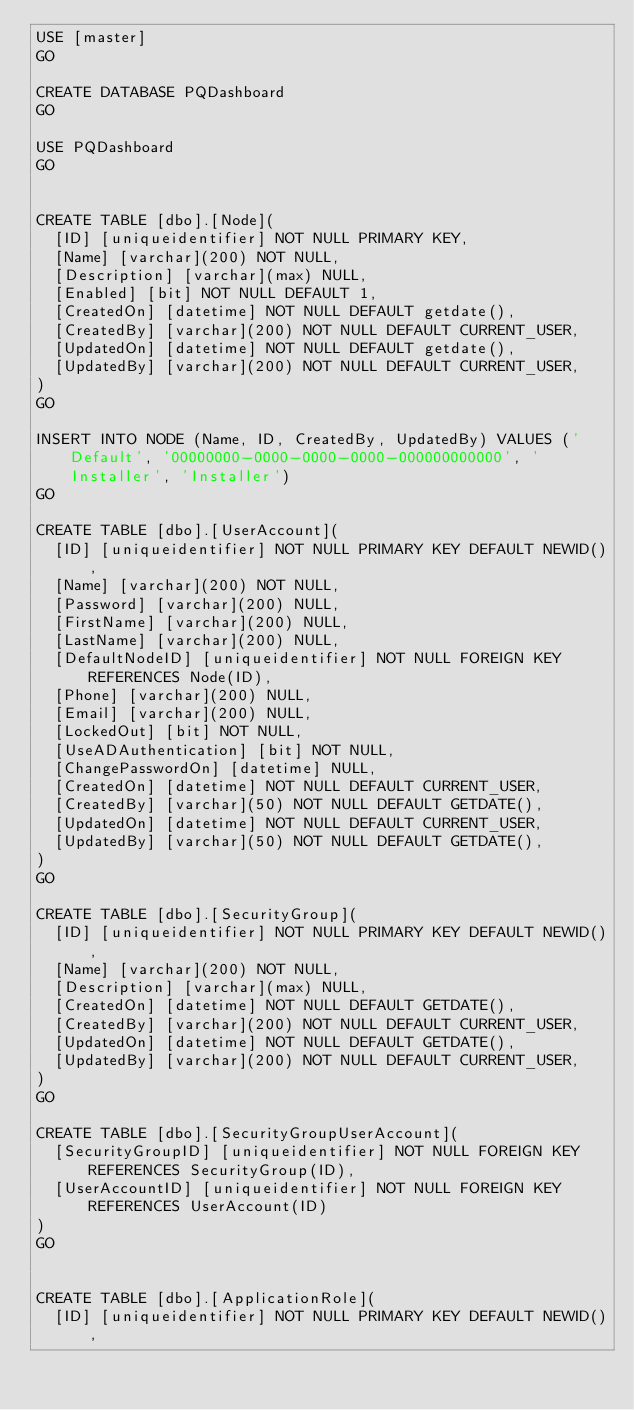<code> <loc_0><loc_0><loc_500><loc_500><_SQL_>USE [master]
GO

CREATE DATABASE PQDashboard
GO

USE PQDashboard
GO


CREATE TABLE [dbo].[Node](
	[ID] [uniqueidentifier] NOT NULL PRIMARY KEY,
	[Name] [varchar](200) NOT NULL,
	[Description] [varchar](max) NULL,
	[Enabled] [bit] NOT NULL DEFAULT 1,
	[CreatedOn] [datetime] NOT NULL DEFAULT getdate(),
	[CreatedBy] [varchar](200) NOT NULL DEFAULT CURRENT_USER,
	[UpdatedOn] [datetime] NOT NULL DEFAULT getdate(),
	[UpdatedBy] [varchar](200) NOT NULL DEFAULT CURRENT_USER,
)
GO

INSERT INTO NODE (Name, ID, CreatedBy, UpdatedBy) VALUES ('Default', '00000000-0000-0000-0000-000000000000', 'Installer', 'Installer')
GO

CREATE TABLE [dbo].[UserAccount](
	[ID] [uniqueidentifier] NOT NULL PRIMARY KEY DEFAULT NEWID(),
	[Name] [varchar](200) NOT NULL,
	[Password] [varchar](200) NULL,
	[FirstName] [varchar](200) NULL,
	[LastName] [varchar](200) NULL,
	[DefaultNodeID] [uniqueidentifier] NOT NULL FOREIGN KEY REFERENCES Node(ID),
	[Phone] [varchar](200) NULL,
	[Email] [varchar](200) NULL,
	[LockedOut] [bit] NOT NULL,
	[UseADAuthentication] [bit] NOT NULL,
	[ChangePasswordOn] [datetime] NULL,
	[CreatedOn] [datetime] NOT NULL DEFAULT CURRENT_USER,
	[CreatedBy] [varchar](50) NOT NULL DEFAULT GETDATE(),
	[UpdatedOn] [datetime] NOT NULL DEFAULT CURRENT_USER,
	[UpdatedBy] [varchar](50) NOT NULL DEFAULT GETDATE(),
)
GO

CREATE TABLE [dbo].[SecurityGroup](
	[ID] [uniqueidentifier] NOT NULL PRIMARY KEY DEFAULT NEWID(),
	[Name] [varchar](200) NOT NULL,
	[Description] [varchar](max) NULL,
	[CreatedOn] [datetime] NOT NULL DEFAULT GETDATE(),
	[CreatedBy] [varchar](200) NOT NULL DEFAULT CURRENT_USER,
	[UpdatedOn] [datetime] NOT NULL DEFAULT GETDATE(),
	[UpdatedBy] [varchar](200) NOT NULL DEFAULT CURRENT_USER,
)
GO

CREATE TABLE [dbo].[SecurityGroupUserAccount](
	[SecurityGroupID] [uniqueidentifier] NOT NULL FOREIGN KEY REFERENCES SecurityGroup(ID),
	[UserAccountID] [uniqueidentifier] NOT NULL FOREIGN KEY REFERENCES UserAccount(ID)
)
GO


CREATE TABLE [dbo].[ApplicationRole](
	[ID] [uniqueidentifier] NOT NULL PRIMARY KEY DEFAULT NEWID(),</code> 